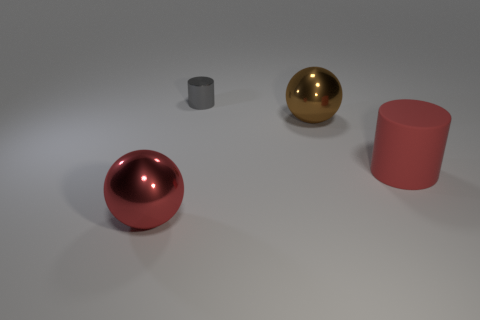Add 3 red rubber cylinders. How many objects exist? 7 Subtract all red cylinders. How many cylinders are left? 1 Subtract 1 cylinders. How many cylinders are left? 1 Add 2 red objects. How many red objects are left? 4 Add 3 big rubber objects. How many big rubber objects exist? 4 Subtract 0 purple blocks. How many objects are left? 4 Subtract all red cylinders. Subtract all yellow cubes. How many cylinders are left? 1 Subtract all tiny objects. Subtract all small red metal balls. How many objects are left? 3 